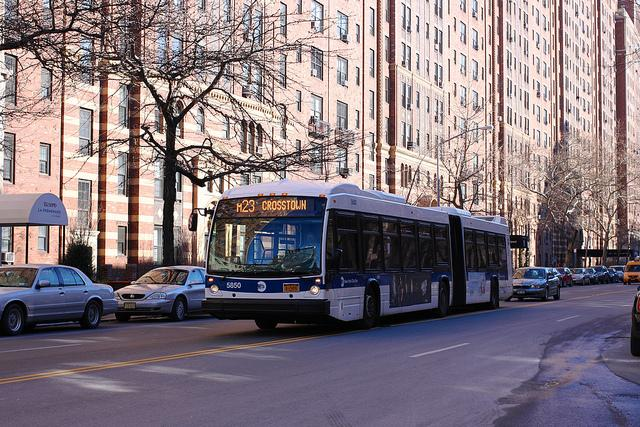What type of parking is shown?

Choices:
A) valet
B) lot
C) parallel
D) diagonal parallel 